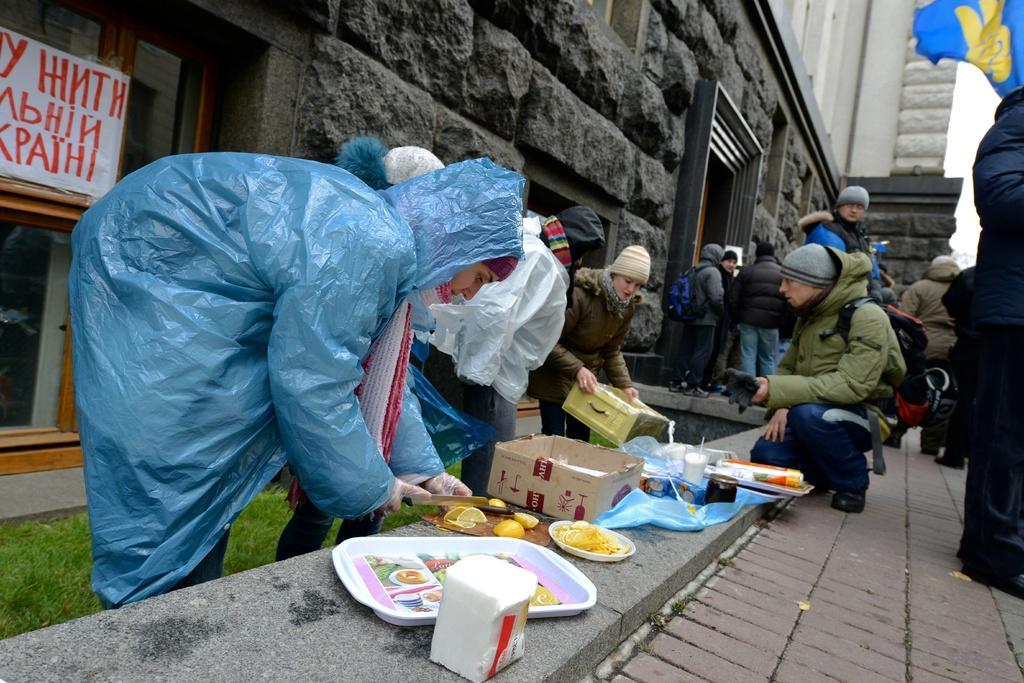Please provide a concise description of this image. In this image I can see a group of people around. They are holding something. I can see tissues,tray,fruits,knife cardboard and some objects on the floor. I can see building and glass window. 